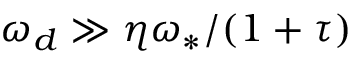Convert formula to latex. <formula><loc_0><loc_0><loc_500><loc_500>\omega _ { d } \gg \eta \omega _ { \ast } / ( 1 + \tau )</formula> 